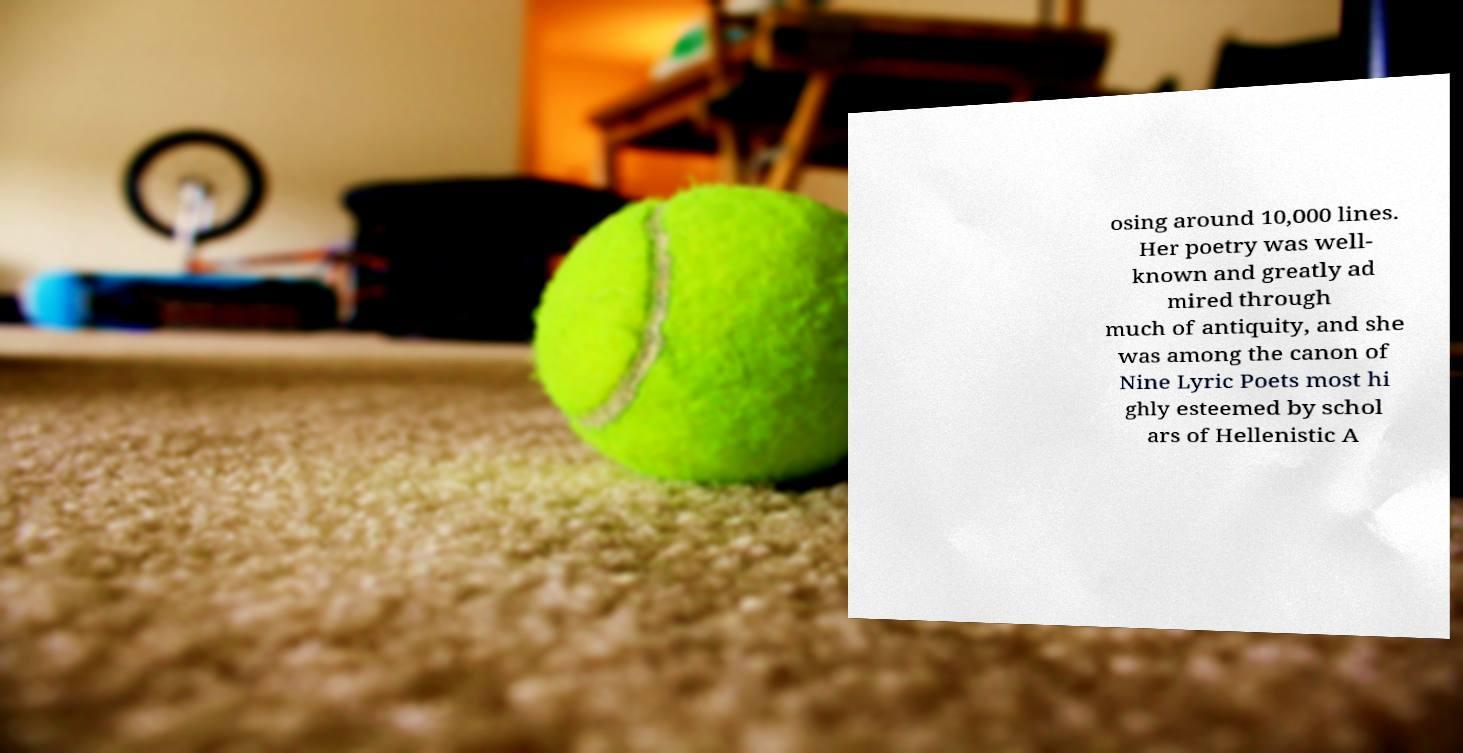Please identify and transcribe the text found in this image. osing around 10,000 lines. Her poetry was well- known and greatly ad mired through much of antiquity, and she was among the canon of Nine Lyric Poets most hi ghly esteemed by schol ars of Hellenistic A 